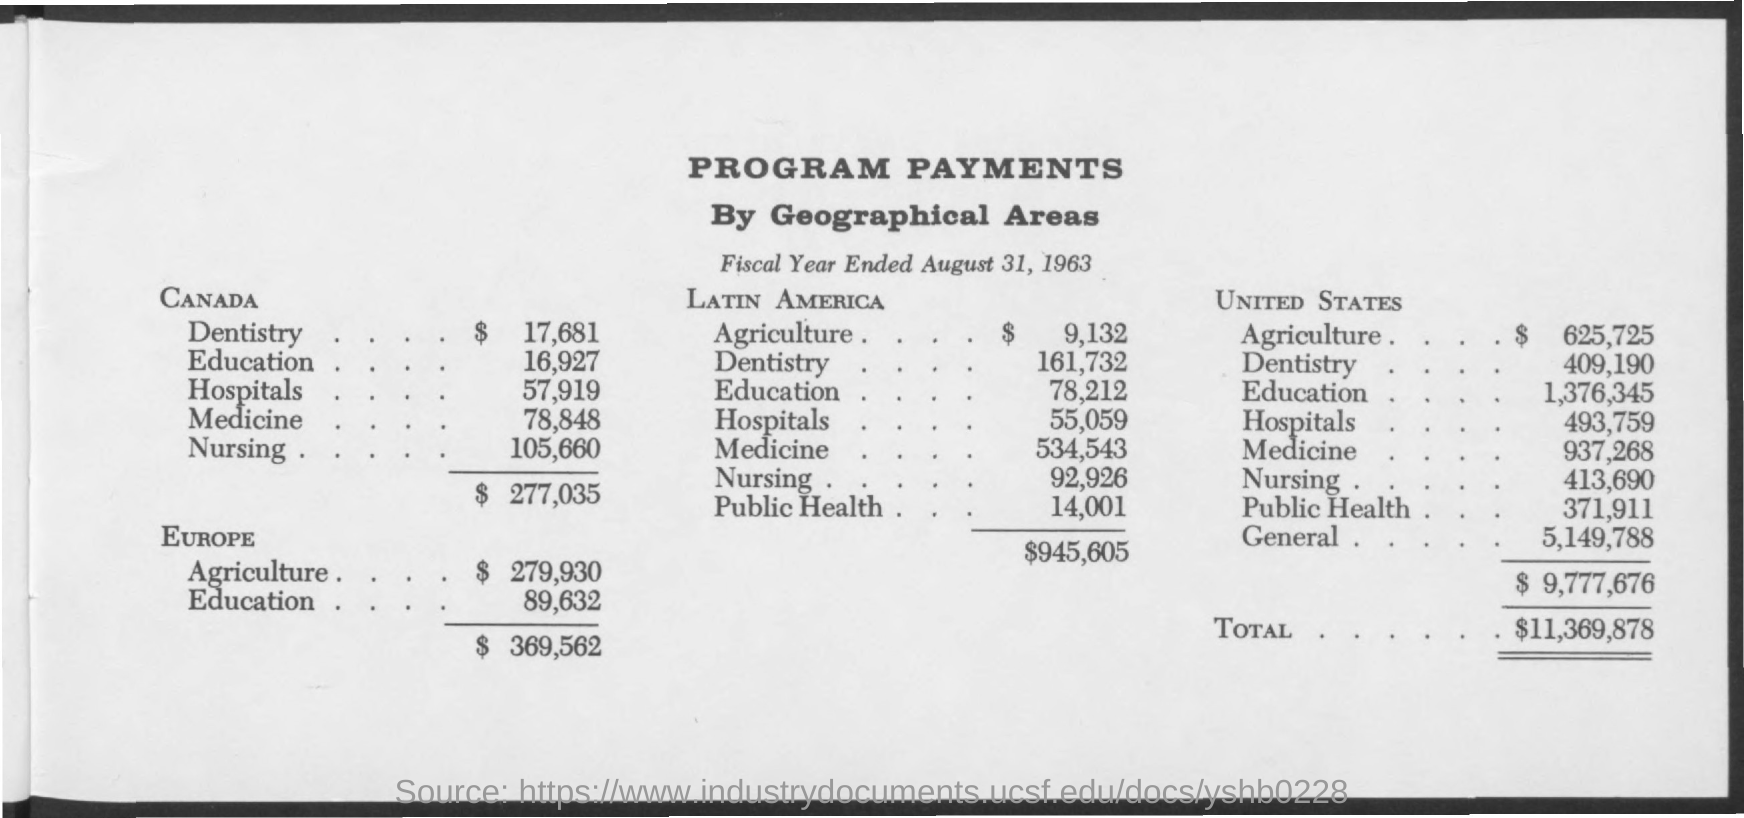Specify some key components in this picture. The first title in the document is 'Program Payments.' The date mentioned in the document is August 31, 1963. 